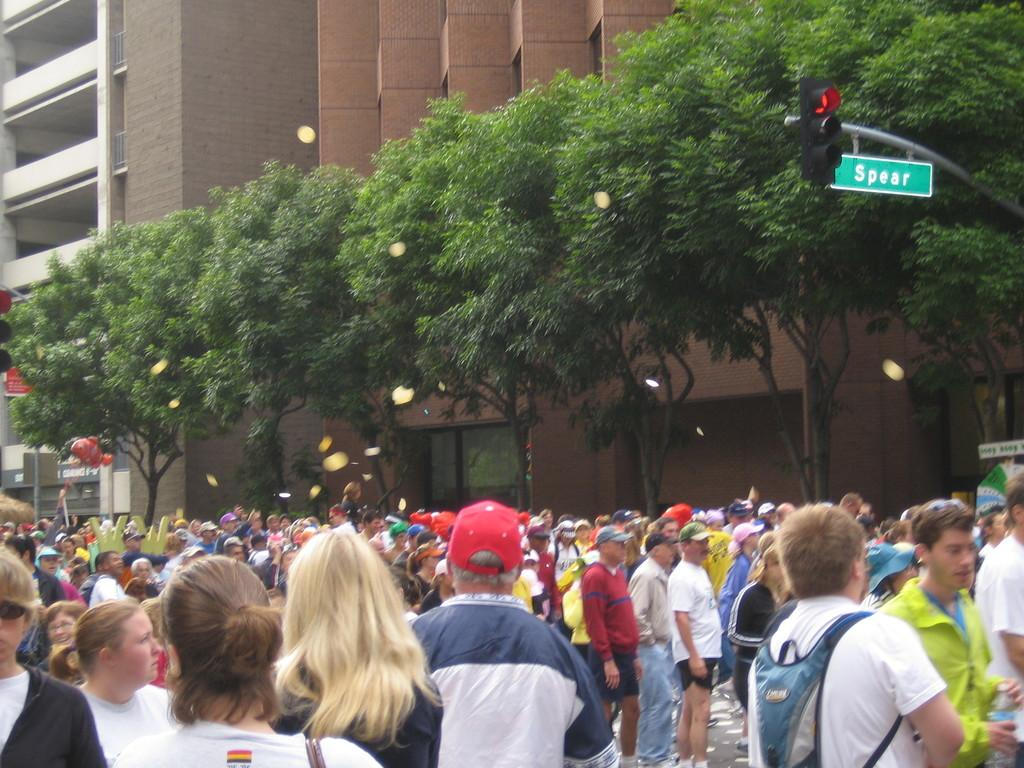What can be seen in the center of the image? There are trees and buildings in the center of the image. What object is located on the right side of the image? There is a traffic pole on the right side of the image. Who or what is present at the bottom of the image? There are people standing at the bottom of the image. How many glasses are visible in the image? There are no glasses present in the image. What type of home is shown in the image? The image does not depict a home; it features trees, buildings, a traffic pole, and people. 